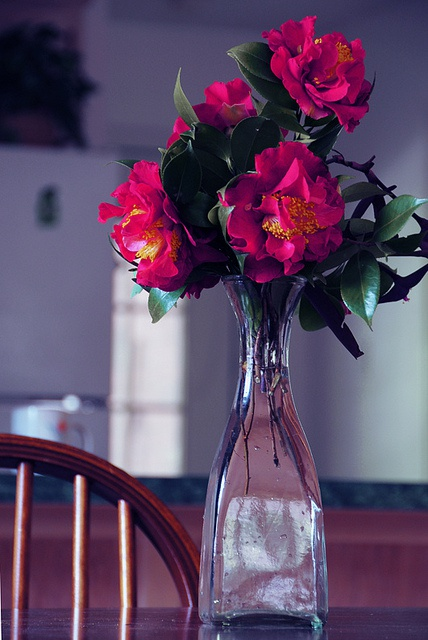Describe the objects in this image and their specific colors. I can see refrigerator in black, gray, purple, lightblue, and darkgray tones, vase in black, purple, darkgray, and gray tones, chair in black, purple, and navy tones, and dining table in black, purple, navy, and gray tones in this image. 